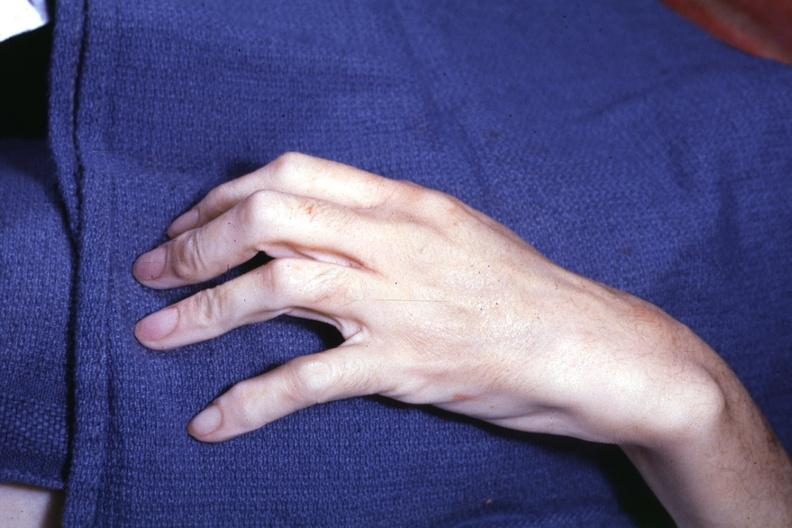what does long fingers interesting case see?
Answer the question using a single word or phrase. Other slides 